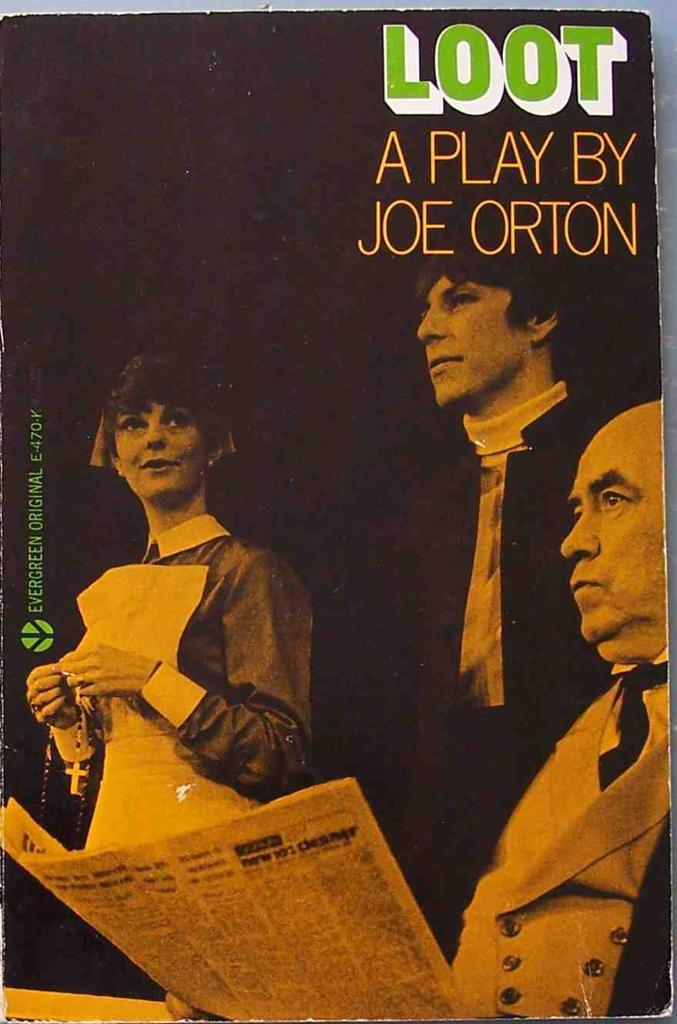Provide a one-sentence caption for the provided image. A playbill for Loot A Play by Joe Orton shows one man reading a newspaper and a lady with a rosary. 